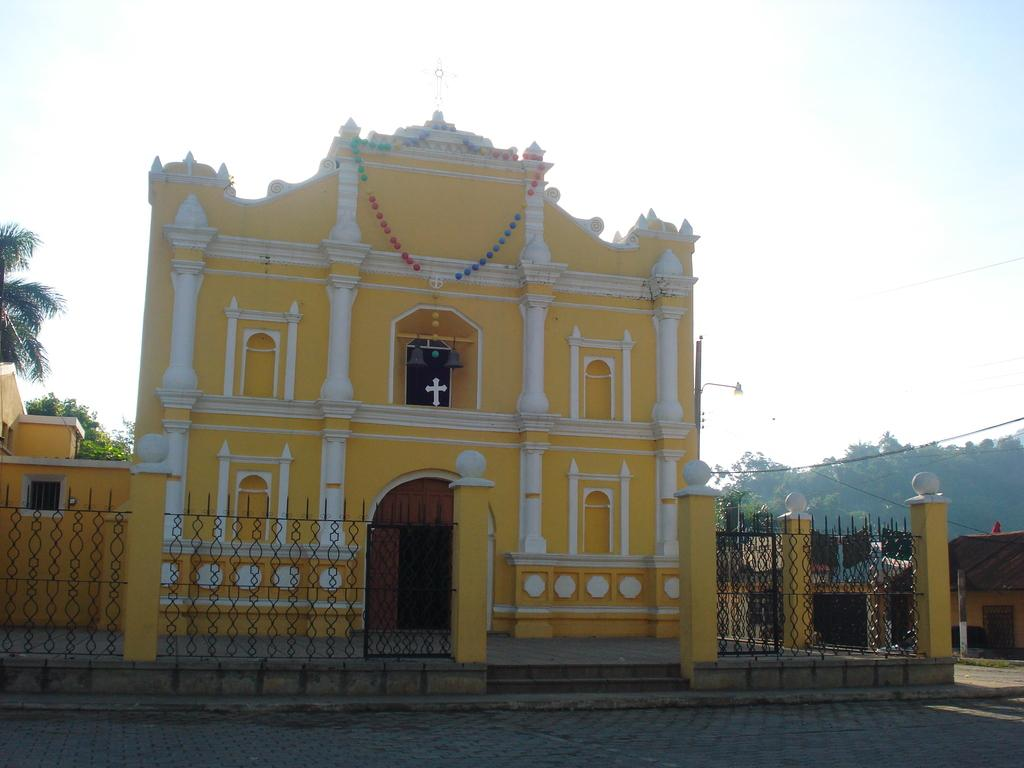What type of building is in the image? There is a church in the image. What religious symbol is present on the church? The church has a cross symbol. What type of vegetation can be seen in the image? There are trees in the image. What type of barrier is present in the image? There is a fence in the image. What architectural feature is present on the church? There are pillars in the image. What type of residential structures are visible in the image? There are houses in the image. What is visible in the background of the image? The sky is visible in the background of the image. What type of machine is being used by the ants in the image? There are no ants or machines present in the image. 